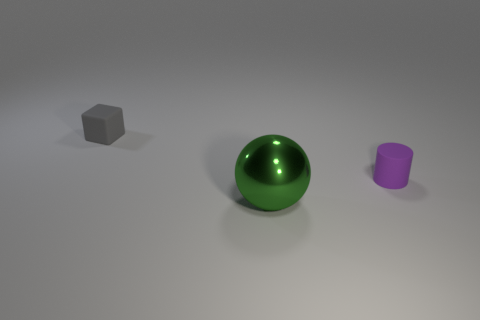Add 2 large green metal balls. How many objects exist? 5 Subtract all cylinders. How many objects are left? 2 Subtract all tiny blocks. Subtract all green objects. How many objects are left? 1 Add 3 purple objects. How many purple objects are left? 4 Add 1 gray objects. How many gray objects exist? 2 Subtract 0 blue spheres. How many objects are left? 3 